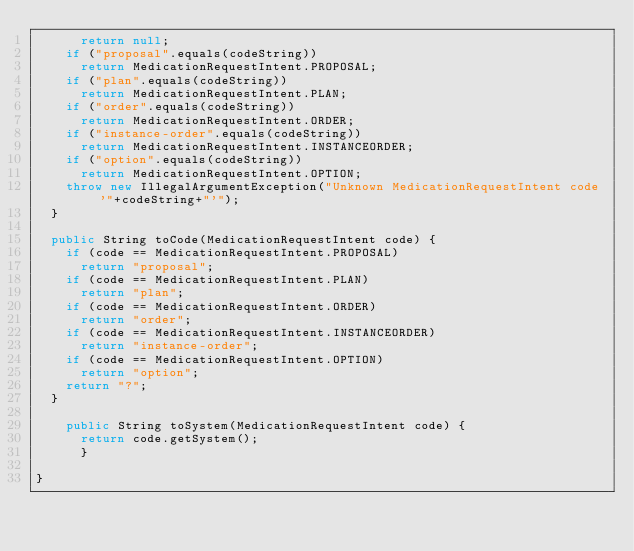Convert code to text. <code><loc_0><loc_0><loc_500><loc_500><_Java_>      return null;
    if ("proposal".equals(codeString))
      return MedicationRequestIntent.PROPOSAL;
    if ("plan".equals(codeString))
      return MedicationRequestIntent.PLAN;
    if ("order".equals(codeString))
      return MedicationRequestIntent.ORDER;
    if ("instance-order".equals(codeString))
      return MedicationRequestIntent.INSTANCEORDER;
    if ("option".equals(codeString))
      return MedicationRequestIntent.OPTION;
    throw new IllegalArgumentException("Unknown MedicationRequestIntent code '"+codeString+"'");
  }

  public String toCode(MedicationRequestIntent code) {
    if (code == MedicationRequestIntent.PROPOSAL)
      return "proposal";
    if (code == MedicationRequestIntent.PLAN)
      return "plan";
    if (code == MedicationRequestIntent.ORDER)
      return "order";
    if (code == MedicationRequestIntent.INSTANCEORDER)
      return "instance-order";
    if (code == MedicationRequestIntent.OPTION)
      return "option";
    return "?";
  }

    public String toSystem(MedicationRequestIntent code) {
      return code.getSystem();
      }

}

</code> 